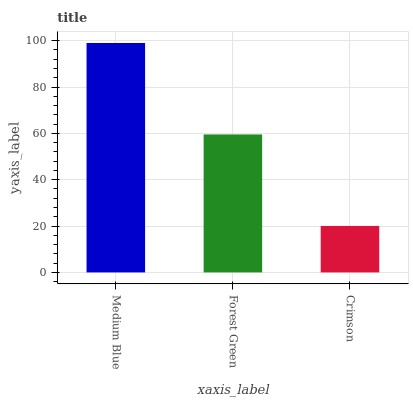Is Crimson the minimum?
Answer yes or no. Yes. Is Medium Blue the maximum?
Answer yes or no. Yes. Is Forest Green the minimum?
Answer yes or no. No. Is Forest Green the maximum?
Answer yes or no. No. Is Medium Blue greater than Forest Green?
Answer yes or no. Yes. Is Forest Green less than Medium Blue?
Answer yes or no. Yes. Is Forest Green greater than Medium Blue?
Answer yes or no. No. Is Medium Blue less than Forest Green?
Answer yes or no. No. Is Forest Green the high median?
Answer yes or no. Yes. Is Forest Green the low median?
Answer yes or no. Yes. Is Medium Blue the high median?
Answer yes or no. No. Is Crimson the low median?
Answer yes or no. No. 